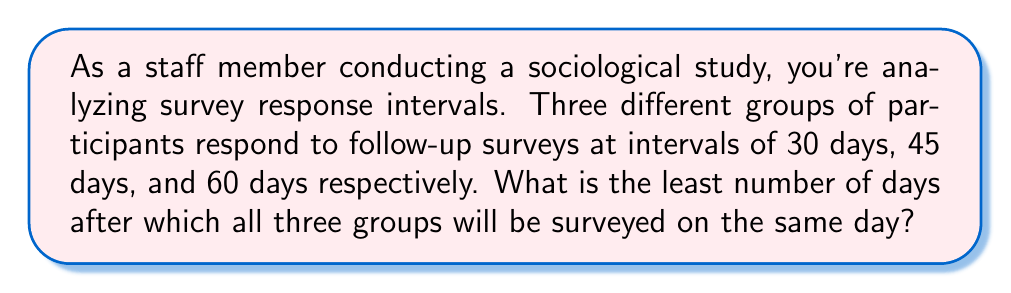Give your solution to this math problem. To solve this problem, we need to find the least common multiple (LCM) of the given intervals: 30, 45, and 60 days.

Step 1: Factor each number into its prime factors.
$30 = 2 \times 3 \times 5$
$45 = 3^2 \times 5$
$60 = 2^2 \times 3 \times 5$

Step 2: Identify the highest power of each prime factor among the numbers.
$2^2$ (from 60)
$3^2$ (from 45)
$5^1$ (from all)

Step 3: Multiply these highest powers together to get the LCM.

$LCM = 2^2 \times 3^2 \times 5 = 4 \times 9 \times 5 = 180$

Therefore, the least number of days after which all three groups will be surveyed on the same day is 180 days.

We can verify this:
$180 \div 30 = 6$ (whole number)
$180 \div 45 = 4$ (whole number)
$180 \div 60 = 3$ (whole number)

This confirms that 180 is divisible by all three intervals, and it's the smallest such number.
Answer: 180 days 